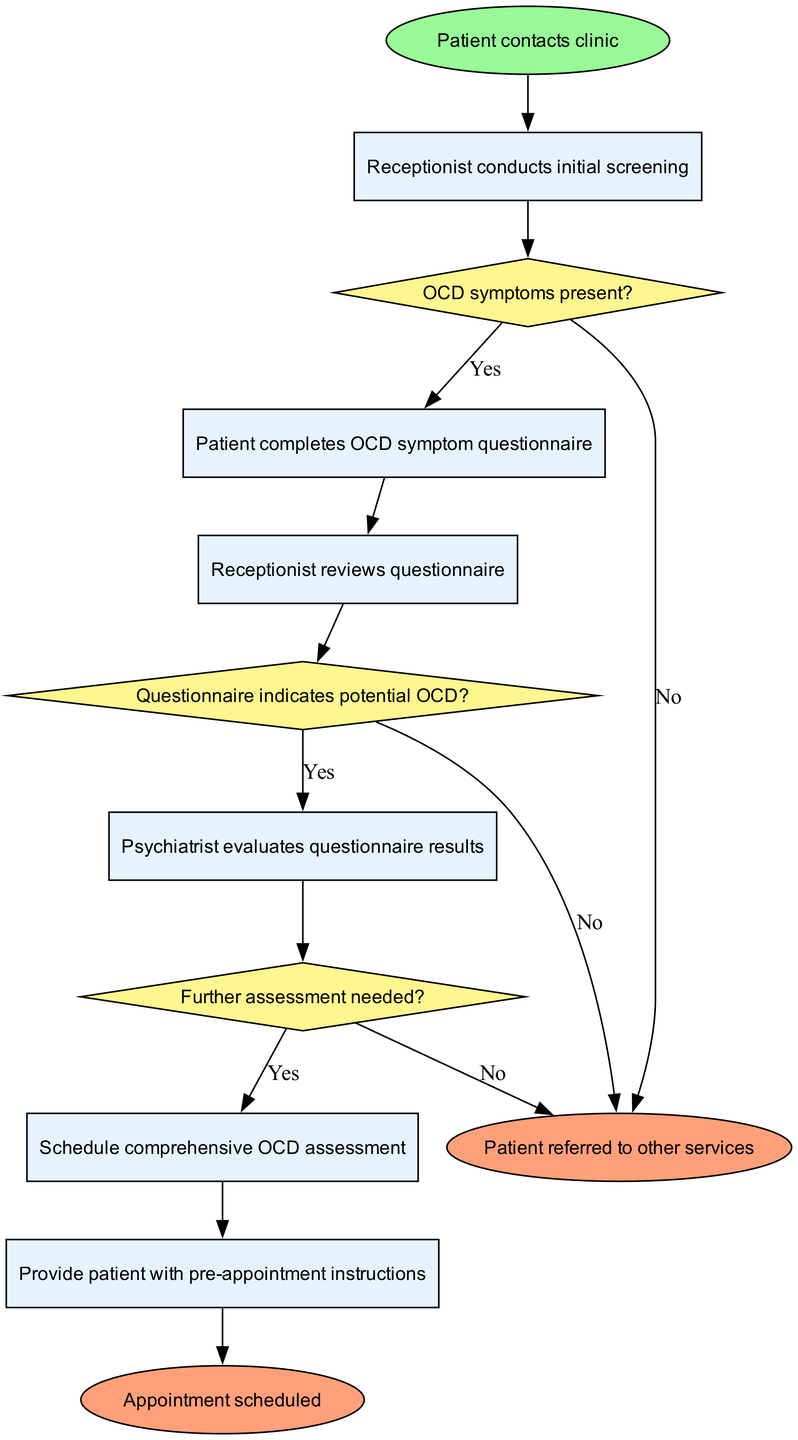What is the starting point of the diagram? The starting point is indicated by the 'start' node, which is labeled "Patient contacts clinic." This node represents the initial action that triggers the entire process.
Answer: Patient contacts clinic How many activities are present in the diagram? The diagram contains six activities, as listed in the "activities" section, which are sequential tasks that occur during the patient intake process.
Answer: 6 What happens if the patient does not have OCD symptoms? If the patient does not have OCD symptoms, according to the decision labeled "OCD symptoms present?", they are referred to an appropriate specialist, ending their current intake process.
Answer: Refer to appropriate specialist Which activity follows the questionnaire completion? After the patient completes the OCD symptom questionnaire, the next activity, as shown in the flow, is that the receptionist reviews the questionnaire.
Answer: Receptionist reviews questionnaire What is the outcome if further assessment is not needed? If further assessment is not needed, the outcome is that the patient receives resources and self-help information instead of scheduling a comprehensive OCD assessment.
Answer: Provide resources and self-help information What decision is made after reviewing the questionnaire? After the questionnaire is reviewed, the decision that follows is whether the questionnaire indicates potential OCD. This forms the basis for evaluating the next steps of the intake process.
Answer: Questionnaire indicates potential OCD What will occur after the psychiatrist evaluates the questionnaire results? After the psychiatrist evaluates the questionnaire results, if further assessment is deemed necessary, the next step will be to schedule a comprehensive OCD assessment.
Answer: Schedule comprehensive OCD assessment What is the final step if appointment scheduling is completed? When the appointment scheduling is successfully completed, the final step in the diagram is that the node labeled "Appointment scheduled" marks the end of the patient intake process.
Answer: Appointment scheduled 